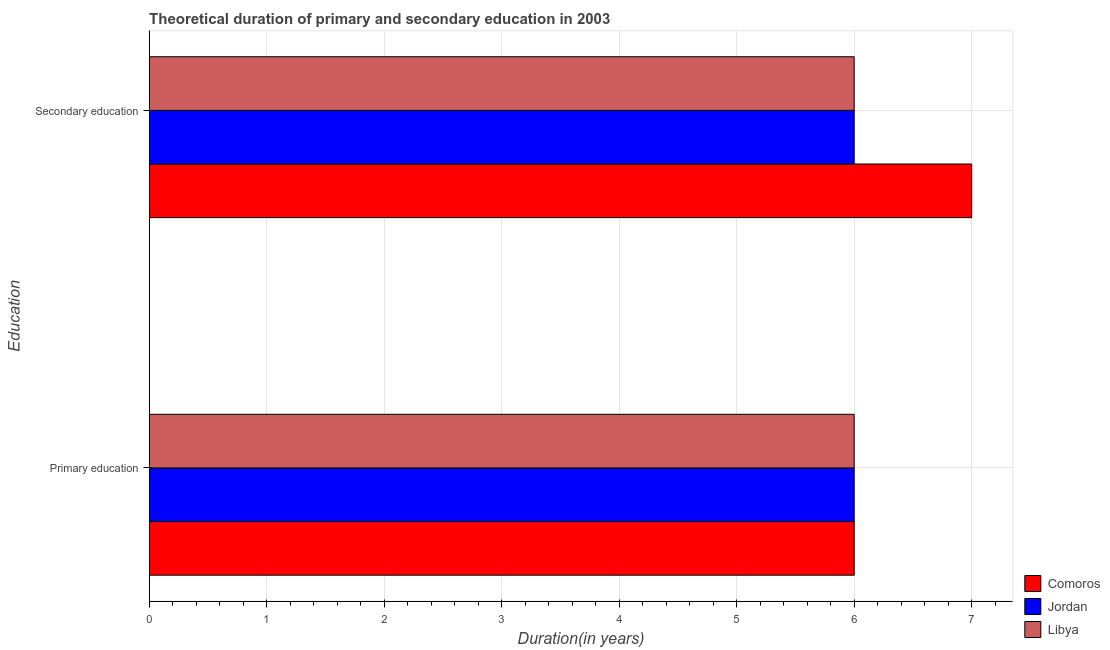How many different coloured bars are there?
Give a very brief answer. 3. How many groups of bars are there?
Your answer should be compact. 2. How many bars are there on the 2nd tick from the top?
Provide a succinct answer. 3. How many bars are there on the 1st tick from the bottom?
Provide a succinct answer. 3. What is the duration of secondary education in Comoros?
Your answer should be very brief. 7. Across all countries, what is the maximum duration of secondary education?
Provide a short and direct response. 7. Across all countries, what is the minimum duration of primary education?
Your answer should be very brief. 6. In which country was the duration of primary education maximum?
Your answer should be very brief. Comoros. In which country was the duration of secondary education minimum?
Offer a very short reply. Jordan. What is the total duration of primary education in the graph?
Make the answer very short. 18. What is the difference between the duration of primary education in Comoros and that in Libya?
Make the answer very short. 0. What is the difference between the duration of secondary education in Comoros and the duration of primary education in Jordan?
Provide a succinct answer. 1. What is the difference between the duration of primary education and duration of secondary education in Libya?
Your answer should be compact. 0. What is the ratio of the duration of secondary education in Libya to that in Comoros?
Offer a very short reply. 0.86. What does the 2nd bar from the top in Primary education represents?
Offer a very short reply. Jordan. What does the 1st bar from the bottom in Primary education represents?
Ensure brevity in your answer.  Comoros. How many bars are there?
Provide a short and direct response. 6. Are all the bars in the graph horizontal?
Provide a succinct answer. Yes. How many countries are there in the graph?
Provide a succinct answer. 3. Does the graph contain grids?
Provide a short and direct response. Yes. What is the title of the graph?
Provide a succinct answer. Theoretical duration of primary and secondary education in 2003. What is the label or title of the X-axis?
Keep it short and to the point. Duration(in years). What is the label or title of the Y-axis?
Give a very brief answer. Education. What is the Duration(in years) of Jordan in Primary education?
Give a very brief answer. 6. What is the Duration(in years) of Libya in Primary education?
Provide a succinct answer. 6. What is the Duration(in years) in Libya in Secondary education?
Offer a very short reply. 6. Across all Education, what is the minimum Duration(in years) of Comoros?
Ensure brevity in your answer.  6. Across all Education, what is the minimum Duration(in years) of Libya?
Provide a short and direct response. 6. What is the total Duration(in years) in Comoros in the graph?
Make the answer very short. 13. What is the total Duration(in years) of Jordan in the graph?
Offer a very short reply. 12. What is the total Duration(in years) in Libya in the graph?
Keep it short and to the point. 12. What is the difference between the Duration(in years) in Comoros in Primary education and that in Secondary education?
Your response must be concise. -1. What is the difference between the Duration(in years) of Jordan in Primary education and that in Secondary education?
Provide a succinct answer. 0. What is the difference between the Duration(in years) of Libya in Primary education and that in Secondary education?
Keep it short and to the point. 0. What is the difference between the Duration(in years) in Comoros in Primary education and the Duration(in years) in Jordan in Secondary education?
Make the answer very short. 0. What is the difference between the Duration(in years) in Comoros in Primary education and the Duration(in years) in Libya in Secondary education?
Your answer should be very brief. 0. What is the difference between the Duration(in years) of Jordan in Primary education and the Duration(in years) of Libya in Secondary education?
Give a very brief answer. 0. What is the average Duration(in years) in Comoros per Education?
Your answer should be very brief. 6.5. What is the average Duration(in years) in Libya per Education?
Ensure brevity in your answer.  6. What is the difference between the Duration(in years) in Comoros and Duration(in years) in Libya in Primary education?
Provide a succinct answer. 0. What is the difference between the Duration(in years) of Jordan and Duration(in years) of Libya in Primary education?
Your answer should be compact. 0. What is the difference between the Duration(in years) in Comoros and Duration(in years) in Jordan in Secondary education?
Provide a succinct answer. 1. What is the ratio of the Duration(in years) in Comoros in Primary education to that in Secondary education?
Your answer should be very brief. 0.86. What is the difference between the highest and the second highest Duration(in years) in Comoros?
Keep it short and to the point. 1. What is the difference between the highest and the lowest Duration(in years) in Comoros?
Keep it short and to the point. 1. 